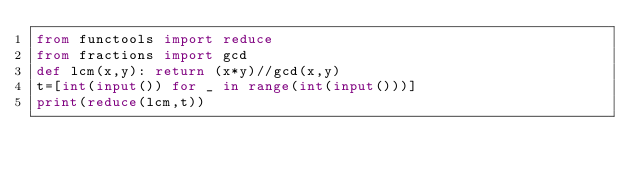<code> <loc_0><loc_0><loc_500><loc_500><_Python_>from functools import reduce
from fractions import gcd
def lcm(x,y): return (x*y)//gcd(x,y)
t=[int(input()) for _ in range(int(input()))]
print(reduce(lcm,t))</code> 